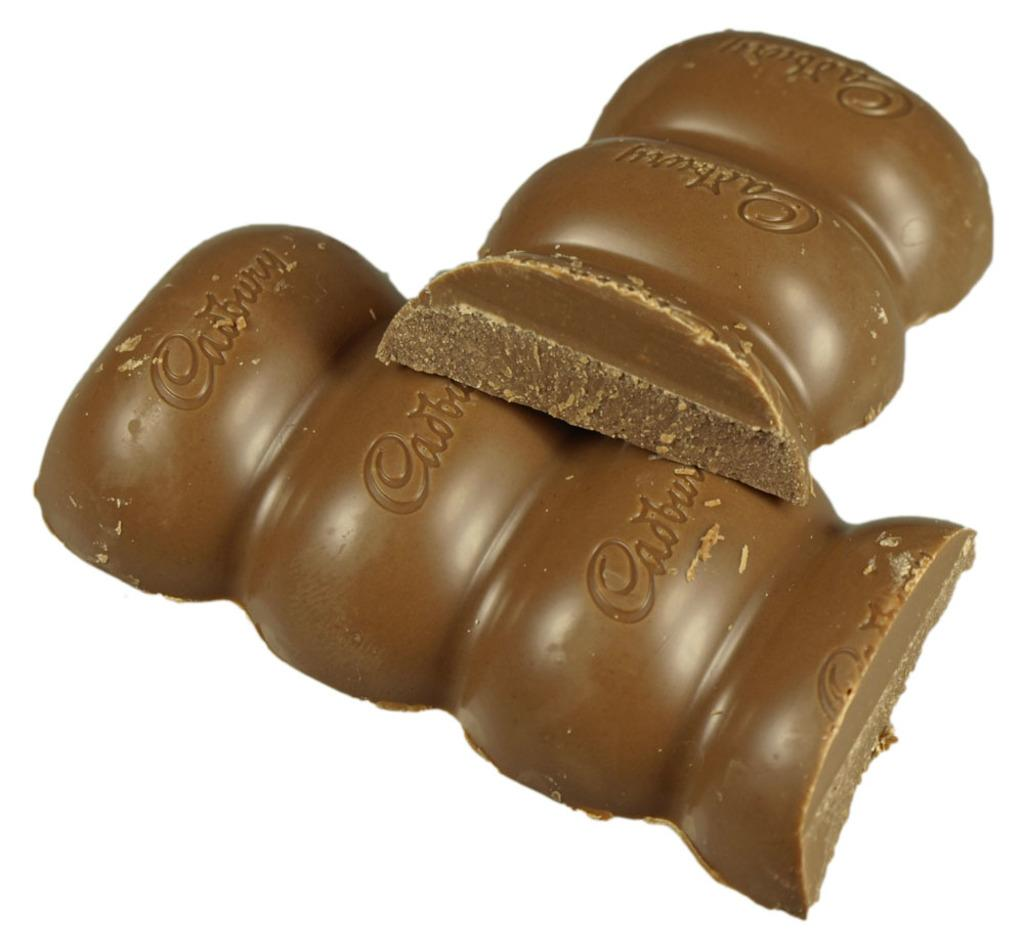What type of food is present in the image? There are chocolates in the image. What color are the chocolates? The chocolates are brown in color. What brand is associated with the chocolates? The word "Cadbury" is written on the chocolates. What type of drink is being poured from the shelf in the image? There is no shelf or drink present in the image; it only features chocolates. 